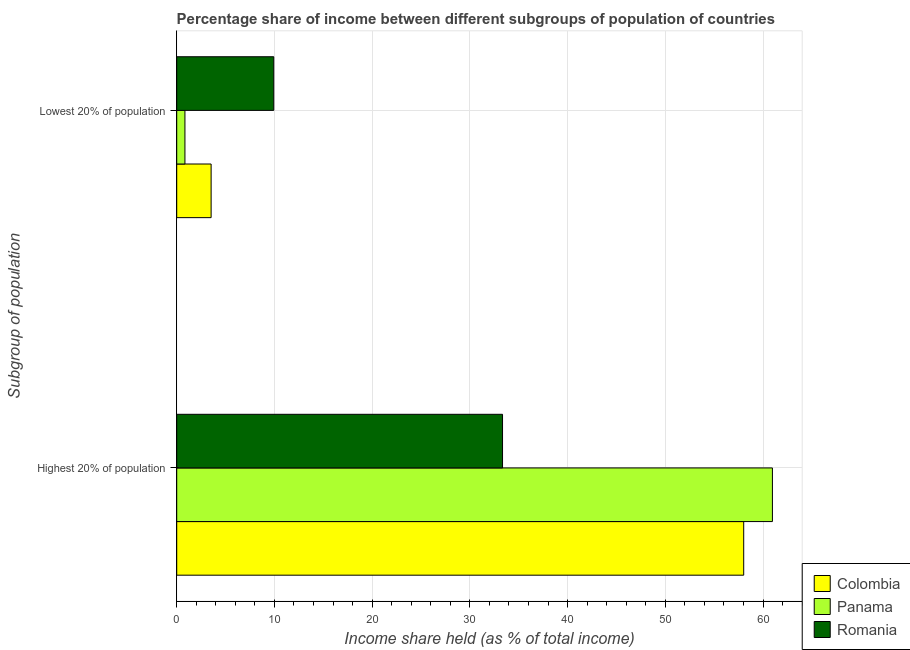How many groups of bars are there?
Provide a short and direct response. 2. Are the number of bars per tick equal to the number of legend labels?
Make the answer very short. Yes. Are the number of bars on each tick of the Y-axis equal?
Your response must be concise. Yes. What is the label of the 2nd group of bars from the top?
Offer a terse response. Highest 20% of population. What is the income share held by highest 20% of the population in Panama?
Offer a terse response. 60.96. Across all countries, what is the maximum income share held by highest 20% of the population?
Ensure brevity in your answer.  60.96. Across all countries, what is the minimum income share held by highest 20% of the population?
Give a very brief answer. 33.34. In which country was the income share held by lowest 20% of the population maximum?
Offer a very short reply. Romania. In which country was the income share held by lowest 20% of the population minimum?
Offer a terse response. Panama. What is the total income share held by highest 20% of the population in the graph?
Provide a short and direct response. 152.32. What is the difference between the income share held by highest 20% of the population in Panama and that in Colombia?
Offer a very short reply. 2.94. What is the difference between the income share held by lowest 20% of the population in Colombia and the income share held by highest 20% of the population in Panama?
Offer a very short reply. -57.44. What is the average income share held by lowest 20% of the population per country?
Your answer should be very brief. 4.76. What is the difference between the income share held by lowest 20% of the population and income share held by highest 20% of the population in Romania?
Provide a short and direct response. -23.41. What is the ratio of the income share held by highest 20% of the population in Panama to that in Romania?
Your response must be concise. 1.83. Is the income share held by highest 20% of the population in Romania less than that in Panama?
Your answer should be compact. Yes. In how many countries, is the income share held by highest 20% of the population greater than the average income share held by highest 20% of the population taken over all countries?
Offer a very short reply. 2. What does the 3rd bar from the bottom in Lowest 20% of population represents?
Your answer should be very brief. Romania. How many bars are there?
Your answer should be very brief. 6. Are the values on the major ticks of X-axis written in scientific E-notation?
Provide a short and direct response. No. Where does the legend appear in the graph?
Ensure brevity in your answer.  Bottom right. How are the legend labels stacked?
Your answer should be very brief. Vertical. What is the title of the graph?
Ensure brevity in your answer.  Percentage share of income between different subgroups of population of countries. What is the label or title of the X-axis?
Give a very brief answer. Income share held (as % of total income). What is the label or title of the Y-axis?
Offer a very short reply. Subgroup of population. What is the Income share held (as % of total income) of Colombia in Highest 20% of population?
Your answer should be compact. 58.02. What is the Income share held (as % of total income) in Panama in Highest 20% of population?
Your answer should be compact. 60.96. What is the Income share held (as % of total income) in Romania in Highest 20% of population?
Keep it short and to the point. 33.34. What is the Income share held (as % of total income) of Colombia in Lowest 20% of population?
Ensure brevity in your answer.  3.52. What is the Income share held (as % of total income) in Panama in Lowest 20% of population?
Your response must be concise. 0.84. What is the Income share held (as % of total income) in Romania in Lowest 20% of population?
Ensure brevity in your answer.  9.93. Across all Subgroup of population, what is the maximum Income share held (as % of total income) of Colombia?
Provide a short and direct response. 58.02. Across all Subgroup of population, what is the maximum Income share held (as % of total income) in Panama?
Provide a succinct answer. 60.96. Across all Subgroup of population, what is the maximum Income share held (as % of total income) in Romania?
Offer a terse response. 33.34. Across all Subgroup of population, what is the minimum Income share held (as % of total income) in Colombia?
Offer a very short reply. 3.52. Across all Subgroup of population, what is the minimum Income share held (as % of total income) of Panama?
Your response must be concise. 0.84. Across all Subgroup of population, what is the minimum Income share held (as % of total income) of Romania?
Your answer should be very brief. 9.93. What is the total Income share held (as % of total income) of Colombia in the graph?
Offer a very short reply. 61.54. What is the total Income share held (as % of total income) in Panama in the graph?
Ensure brevity in your answer.  61.8. What is the total Income share held (as % of total income) of Romania in the graph?
Your answer should be compact. 43.27. What is the difference between the Income share held (as % of total income) in Colombia in Highest 20% of population and that in Lowest 20% of population?
Your answer should be compact. 54.5. What is the difference between the Income share held (as % of total income) of Panama in Highest 20% of population and that in Lowest 20% of population?
Make the answer very short. 60.12. What is the difference between the Income share held (as % of total income) in Romania in Highest 20% of population and that in Lowest 20% of population?
Your answer should be very brief. 23.41. What is the difference between the Income share held (as % of total income) in Colombia in Highest 20% of population and the Income share held (as % of total income) in Panama in Lowest 20% of population?
Provide a short and direct response. 57.18. What is the difference between the Income share held (as % of total income) in Colombia in Highest 20% of population and the Income share held (as % of total income) in Romania in Lowest 20% of population?
Provide a short and direct response. 48.09. What is the difference between the Income share held (as % of total income) in Panama in Highest 20% of population and the Income share held (as % of total income) in Romania in Lowest 20% of population?
Ensure brevity in your answer.  51.03. What is the average Income share held (as % of total income) in Colombia per Subgroup of population?
Offer a very short reply. 30.77. What is the average Income share held (as % of total income) in Panama per Subgroup of population?
Offer a terse response. 30.9. What is the average Income share held (as % of total income) of Romania per Subgroup of population?
Provide a short and direct response. 21.64. What is the difference between the Income share held (as % of total income) in Colombia and Income share held (as % of total income) in Panama in Highest 20% of population?
Ensure brevity in your answer.  -2.94. What is the difference between the Income share held (as % of total income) in Colombia and Income share held (as % of total income) in Romania in Highest 20% of population?
Give a very brief answer. 24.68. What is the difference between the Income share held (as % of total income) in Panama and Income share held (as % of total income) in Romania in Highest 20% of population?
Ensure brevity in your answer.  27.62. What is the difference between the Income share held (as % of total income) of Colombia and Income share held (as % of total income) of Panama in Lowest 20% of population?
Make the answer very short. 2.68. What is the difference between the Income share held (as % of total income) in Colombia and Income share held (as % of total income) in Romania in Lowest 20% of population?
Your answer should be compact. -6.41. What is the difference between the Income share held (as % of total income) in Panama and Income share held (as % of total income) in Romania in Lowest 20% of population?
Your answer should be very brief. -9.09. What is the ratio of the Income share held (as % of total income) in Colombia in Highest 20% of population to that in Lowest 20% of population?
Give a very brief answer. 16.48. What is the ratio of the Income share held (as % of total income) of Panama in Highest 20% of population to that in Lowest 20% of population?
Keep it short and to the point. 72.57. What is the ratio of the Income share held (as % of total income) in Romania in Highest 20% of population to that in Lowest 20% of population?
Ensure brevity in your answer.  3.36. What is the difference between the highest and the second highest Income share held (as % of total income) in Colombia?
Your response must be concise. 54.5. What is the difference between the highest and the second highest Income share held (as % of total income) in Panama?
Your answer should be compact. 60.12. What is the difference between the highest and the second highest Income share held (as % of total income) in Romania?
Your answer should be compact. 23.41. What is the difference between the highest and the lowest Income share held (as % of total income) of Colombia?
Your response must be concise. 54.5. What is the difference between the highest and the lowest Income share held (as % of total income) in Panama?
Give a very brief answer. 60.12. What is the difference between the highest and the lowest Income share held (as % of total income) in Romania?
Offer a terse response. 23.41. 